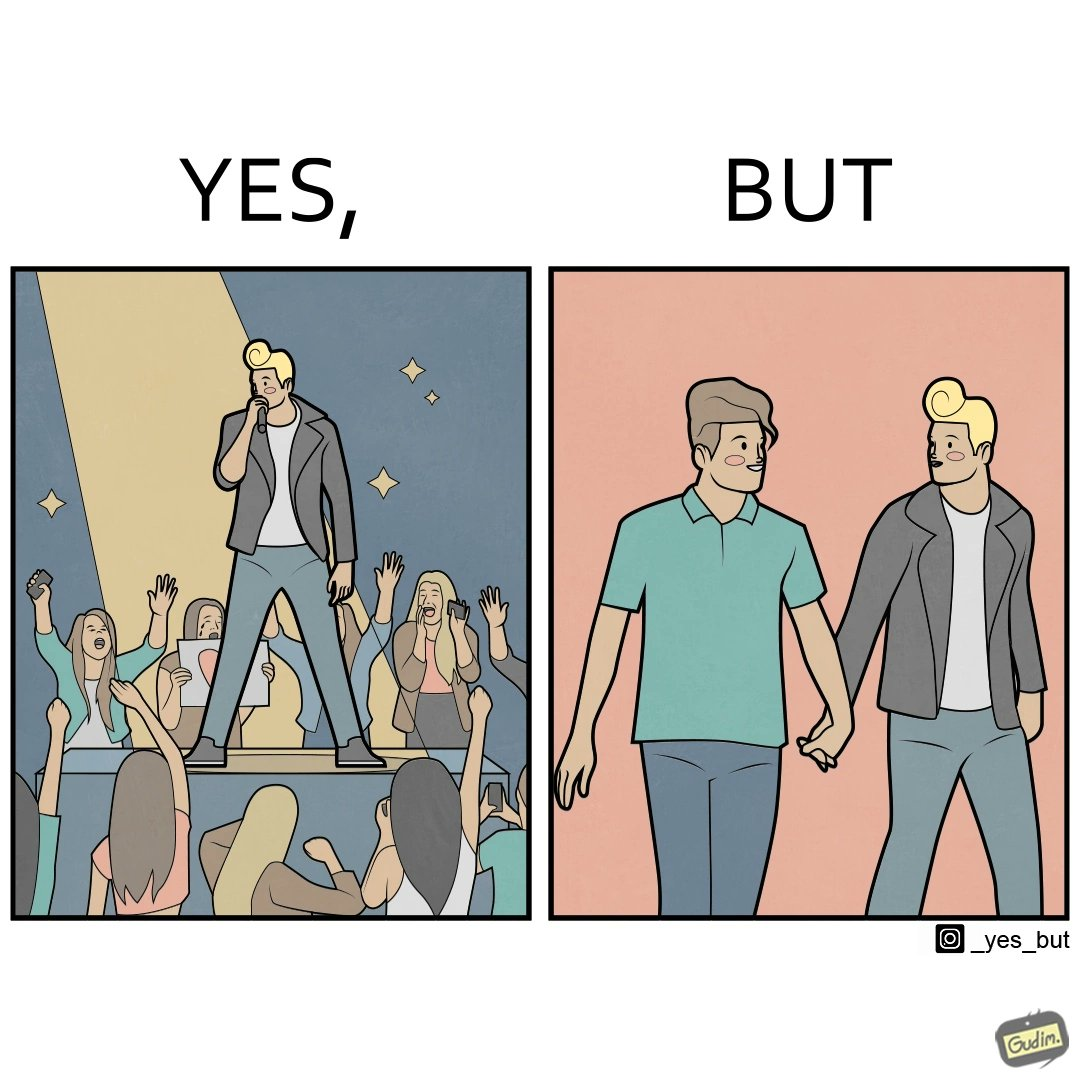What is shown in the left half versus the right half of this image? In the left part of the image: The person shows a man singing on a platform under a spotlight. There are several girls around the platform enjoying his singing and cheering for him. A few girls are taking his photos using their phone and a few also have a poster with heart drawn on it. In the right part of the image: The image shows two men holding hands. 